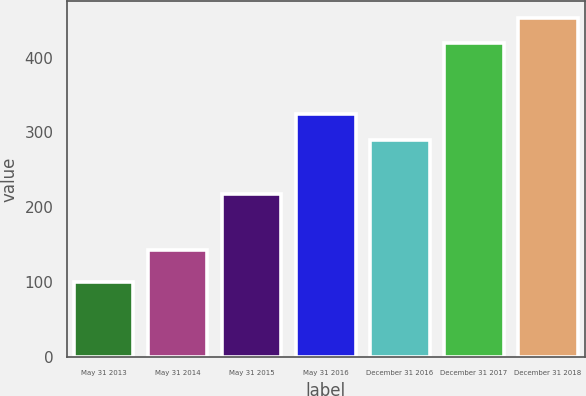Convert chart. <chart><loc_0><loc_0><loc_500><loc_500><bar_chart><fcel>May 31 2013<fcel>May 31 2014<fcel>May 31 2015<fcel>May 31 2016<fcel>December 31 2016<fcel>December 31 2017<fcel>December 31 2018<nl><fcel>100<fcel>143.14<fcel>218.13<fcel>324.92<fcel>290.37<fcel>419.54<fcel>452.72<nl></chart> 